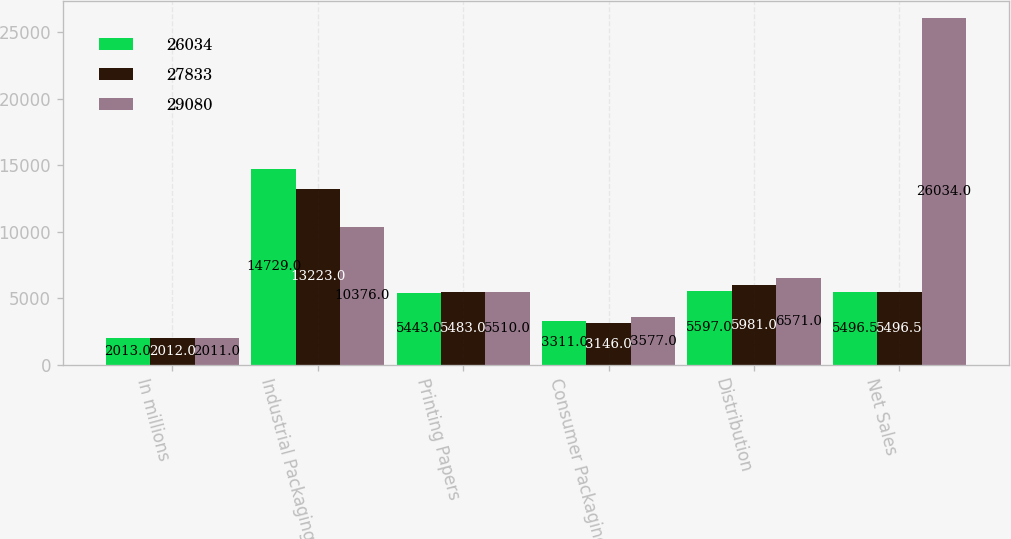Convert chart. <chart><loc_0><loc_0><loc_500><loc_500><stacked_bar_chart><ecel><fcel>In millions<fcel>Industrial Packaging<fcel>Printing Papers<fcel>Consumer Packaging<fcel>Distribution<fcel>Net Sales<nl><fcel>26034<fcel>2013<fcel>14729<fcel>5443<fcel>3311<fcel>5597<fcel>5496.5<nl><fcel>27833<fcel>2012<fcel>13223<fcel>5483<fcel>3146<fcel>5981<fcel>5496.5<nl><fcel>29080<fcel>2011<fcel>10376<fcel>5510<fcel>3577<fcel>6571<fcel>26034<nl></chart> 